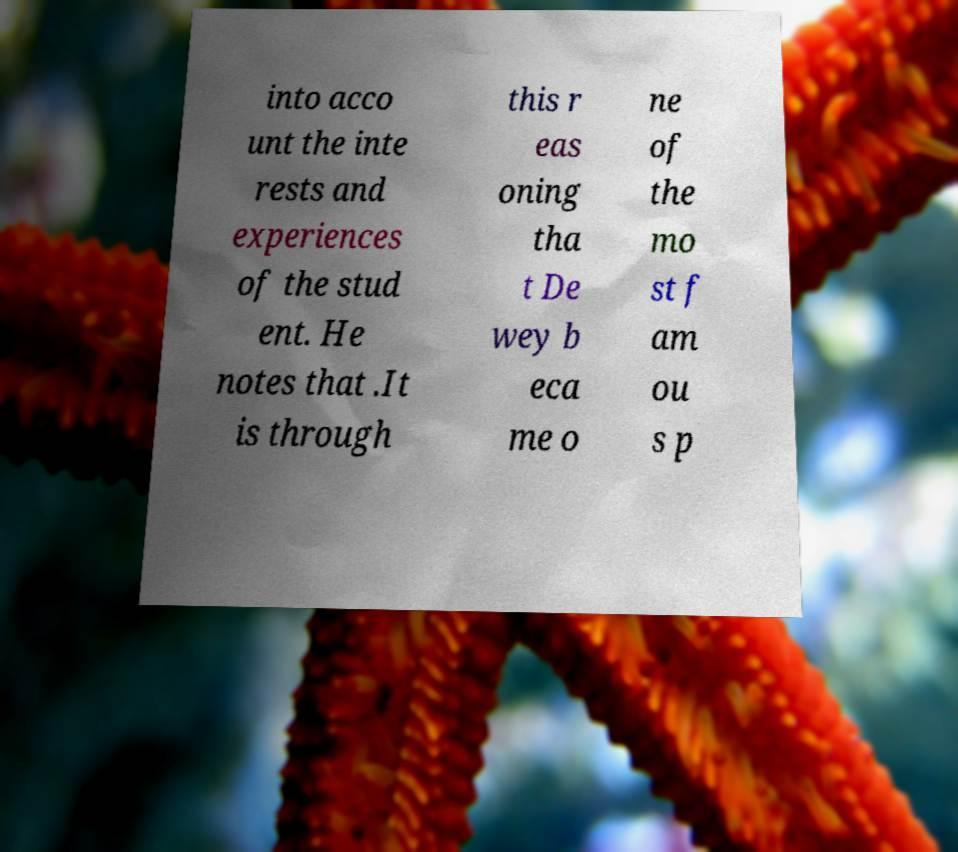I need the written content from this picture converted into text. Can you do that? into acco unt the inte rests and experiences of the stud ent. He notes that .It is through this r eas oning tha t De wey b eca me o ne of the mo st f am ou s p 